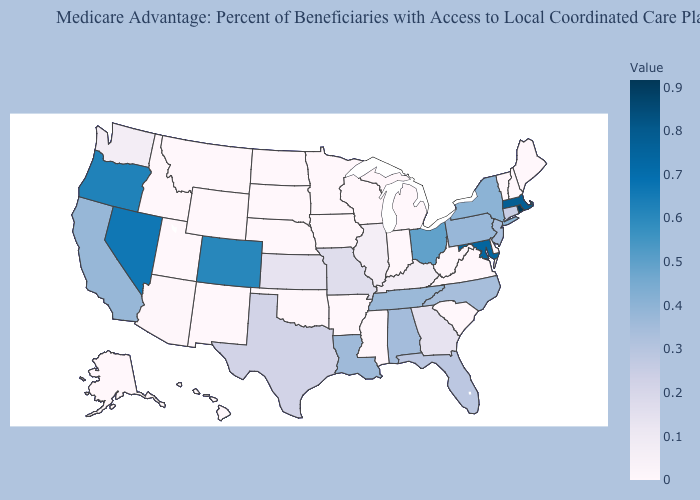Does Nevada have the highest value in the West?
Give a very brief answer. Yes. Among the states that border Maryland , does Pennsylvania have the lowest value?
Short answer required. No. Does Oklahoma have the highest value in the USA?
Concise answer only. No. Which states have the lowest value in the MidWest?
Concise answer only. Iowa, Indiana, Michigan, Minnesota, North Dakota, Nebraska, South Dakota, Wisconsin. 